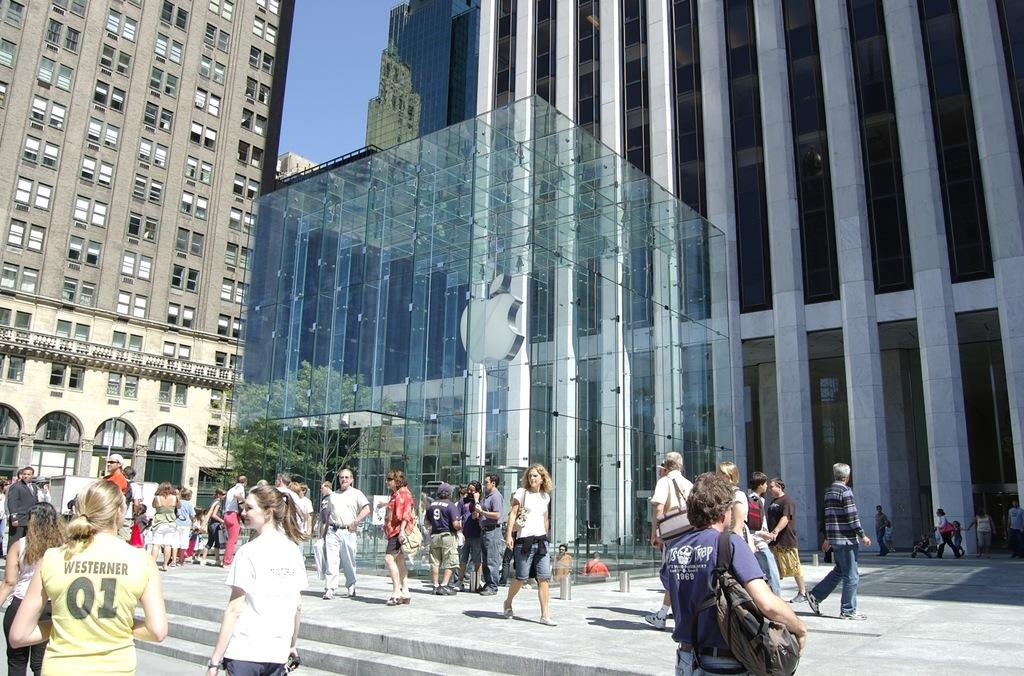What can be seen at the bottom of the image? There are many people at the bottom of the image. What is the main symbol or object in the middle of the image? There is a logo of an apple in the middle of the image. What type of structures can be seen in the background of the image? There are buildings visible in the background of the image. What songs are being sung by the people at the bottom of the image? There is no information about songs being sung in the image. How does the behavior of the people at the bottom of the image differ from those in the background? The image does not provide enough information to compare the behavior of people in the foreground and background. 